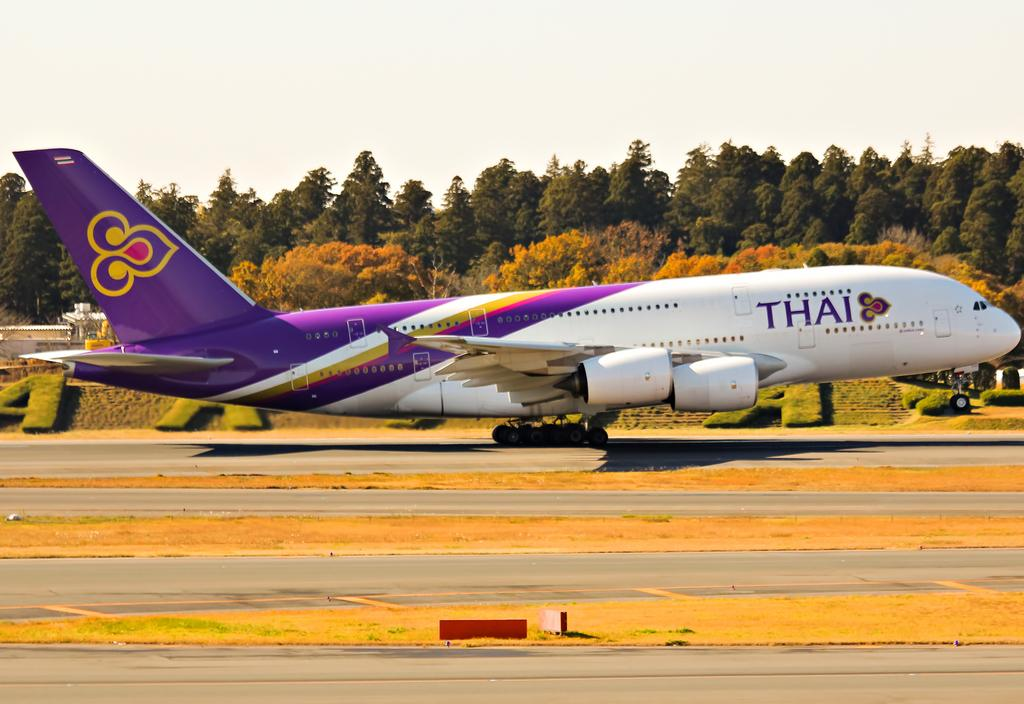<image>
Offer a succinct explanation of the picture presented. A white and purple jet airplane with the name Thai on it. 